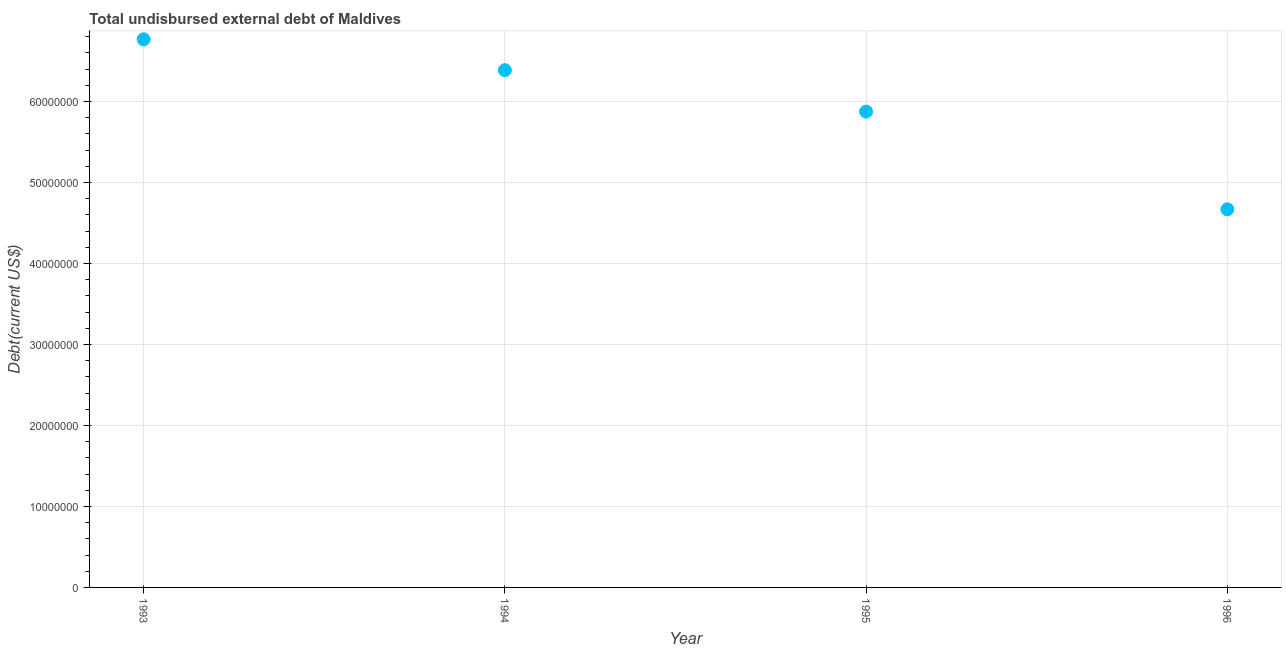What is the total debt in 1993?
Your answer should be compact. 6.77e+07. Across all years, what is the maximum total debt?
Offer a very short reply. 6.77e+07. Across all years, what is the minimum total debt?
Offer a very short reply. 4.67e+07. In which year was the total debt maximum?
Give a very brief answer. 1993. What is the sum of the total debt?
Provide a succinct answer. 2.37e+08. What is the difference between the total debt in 1994 and 1996?
Offer a terse response. 1.72e+07. What is the average total debt per year?
Give a very brief answer. 5.92e+07. What is the median total debt?
Your answer should be very brief. 6.13e+07. What is the ratio of the total debt in 1994 to that in 1995?
Give a very brief answer. 1.09. Is the difference between the total debt in 1994 and 1996 greater than the difference between any two years?
Give a very brief answer. No. What is the difference between the highest and the second highest total debt?
Keep it short and to the point. 3.80e+06. What is the difference between the highest and the lowest total debt?
Offer a very short reply. 2.10e+07. In how many years, is the total debt greater than the average total debt taken over all years?
Provide a short and direct response. 2. Does the total debt monotonically increase over the years?
Give a very brief answer. No. How many dotlines are there?
Offer a terse response. 1. How many years are there in the graph?
Make the answer very short. 4. What is the difference between two consecutive major ticks on the Y-axis?
Give a very brief answer. 1.00e+07. Are the values on the major ticks of Y-axis written in scientific E-notation?
Your answer should be very brief. No. Does the graph contain grids?
Your answer should be compact. Yes. What is the title of the graph?
Ensure brevity in your answer.  Total undisbursed external debt of Maldives. What is the label or title of the Y-axis?
Make the answer very short. Debt(current US$). What is the Debt(current US$) in 1993?
Offer a very short reply. 6.77e+07. What is the Debt(current US$) in 1994?
Ensure brevity in your answer.  6.39e+07. What is the Debt(current US$) in 1995?
Offer a very short reply. 5.87e+07. What is the Debt(current US$) in 1996?
Offer a very short reply. 4.67e+07. What is the difference between the Debt(current US$) in 1993 and 1994?
Provide a short and direct response. 3.80e+06. What is the difference between the Debt(current US$) in 1993 and 1995?
Offer a very short reply. 8.92e+06. What is the difference between the Debt(current US$) in 1993 and 1996?
Give a very brief answer. 2.10e+07. What is the difference between the Debt(current US$) in 1994 and 1995?
Give a very brief answer. 5.12e+06. What is the difference between the Debt(current US$) in 1994 and 1996?
Make the answer very short. 1.72e+07. What is the difference between the Debt(current US$) in 1995 and 1996?
Make the answer very short. 1.21e+07. What is the ratio of the Debt(current US$) in 1993 to that in 1994?
Your answer should be compact. 1.06. What is the ratio of the Debt(current US$) in 1993 to that in 1995?
Provide a succinct answer. 1.15. What is the ratio of the Debt(current US$) in 1993 to that in 1996?
Offer a terse response. 1.45. What is the ratio of the Debt(current US$) in 1994 to that in 1995?
Provide a short and direct response. 1.09. What is the ratio of the Debt(current US$) in 1994 to that in 1996?
Your answer should be compact. 1.37. What is the ratio of the Debt(current US$) in 1995 to that in 1996?
Ensure brevity in your answer.  1.26. 